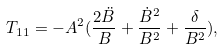<formula> <loc_0><loc_0><loc_500><loc_500>T _ { 1 1 } = - A ^ { 2 } ( \frac { 2 \ddot { B } } { B } + \frac { \dot { B } ^ { 2 } } { B ^ { 2 } } + \frac { \delta } { B ^ { 2 } } ) ,</formula> 